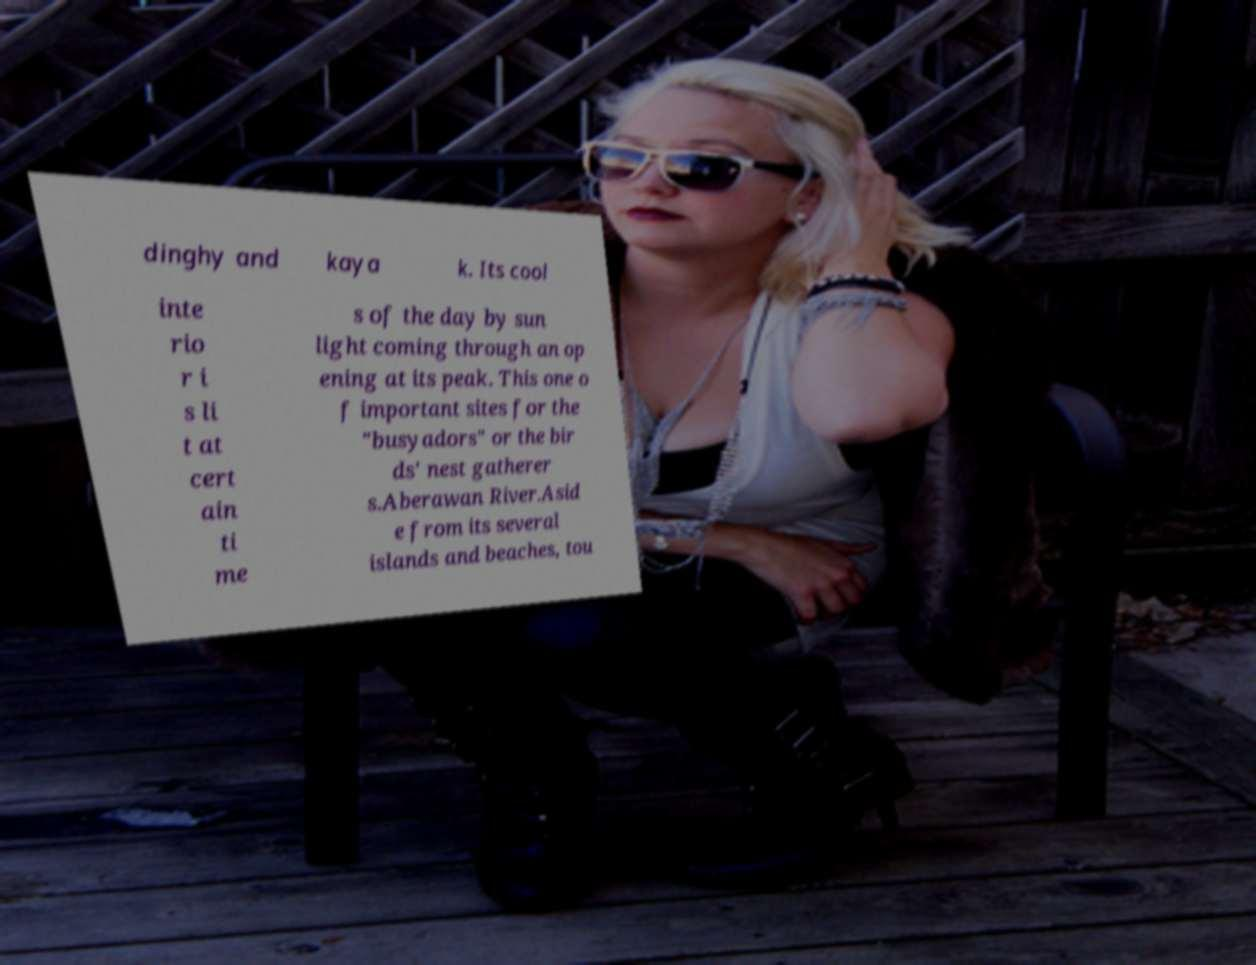Please read and relay the text visible in this image. What does it say? dinghy and kaya k. Its cool inte rio r i s li t at cert ain ti me s of the day by sun light coming through an op ening at its peak. This one o f important sites for the "busyadors" or the bir ds' nest gatherer s.Aberawan River.Asid e from its several islands and beaches, tou 